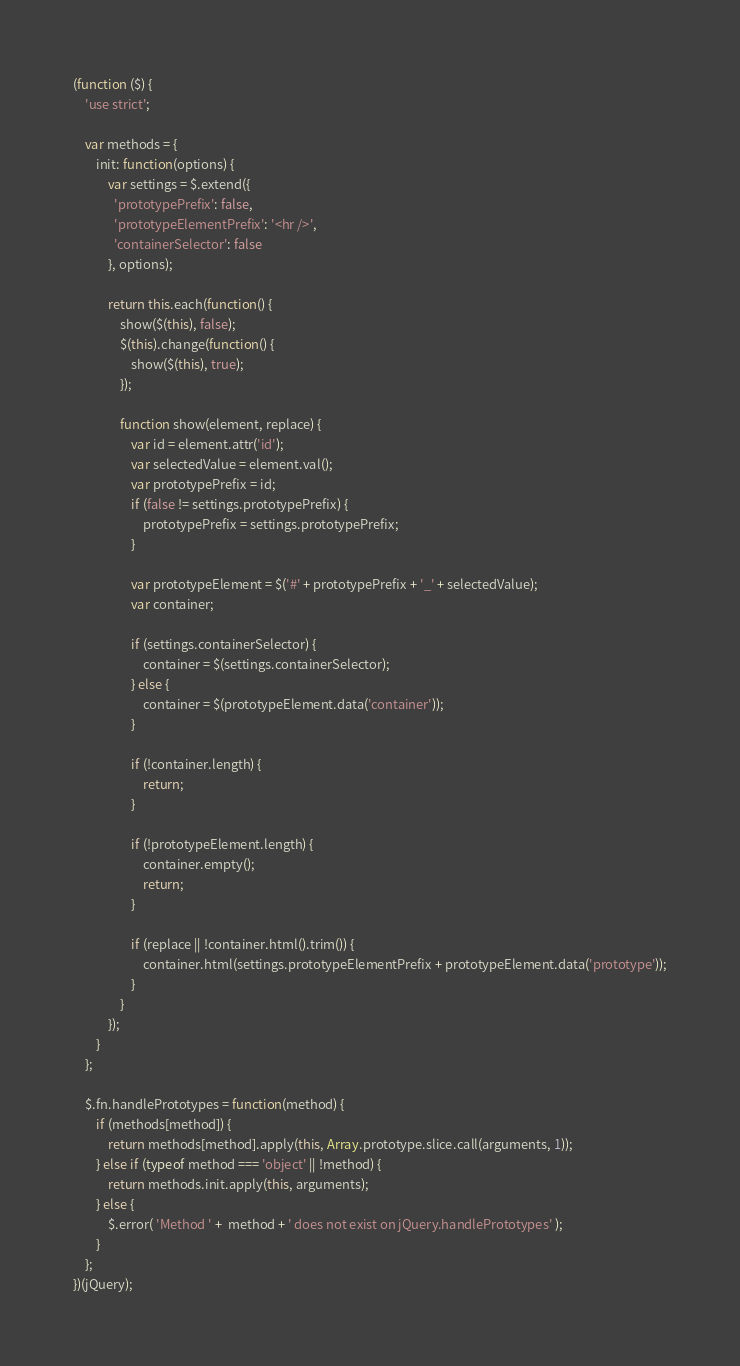<code> <loc_0><loc_0><loc_500><loc_500><_JavaScript_>(function ($) {
    'use strict';

    var methods = {
        init: function(options) {
            var settings = $.extend({
              'prototypePrefix': false,
              'prototypeElementPrefix': '<hr />',
              'containerSelector': false
            }, options);

            return this.each(function() {
                show($(this), false);
                $(this).change(function() {
                    show($(this), true);
                });

                function show(element, replace) {
                    var id = element.attr('id');
                    var selectedValue = element.val();
                    var prototypePrefix = id;
                    if (false != settings.prototypePrefix) {
                        prototypePrefix = settings.prototypePrefix;
                    }

                    var prototypeElement = $('#' + prototypePrefix + '_' + selectedValue);
                    var container;

                    if (settings.containerSelector) {
                        container = $(settings.containerSelector);
                    } else {
                        container = $(prototypeElement.data('container'));
                    }

                    if (!container.length) {
                        return;
                    }

                    if (!prototypeElement.length) {
                        container.empty();
                        return;
                    }

                    if (replace || !container.html().trim()) {
                        container.html(settings.prototypeElementPrefix + prototypeElement.data('prototype'));
                    }
                }
            });
        }
    };

    $.fn.handlePrototypes = function(method) {
        if (methods[method]) {
            return methods[method].apply(this, Array.prototype.slice.call(arguments, 1));
        } else if (typeof method === 'object' || !method) {
            return methods.init.apply(this, arguments);
        } else {
            $.error( 'Method ' +  method + ' does not exist on jQuery.handlePrototypes' );
        }
    };
})(jQuery);
</code> 